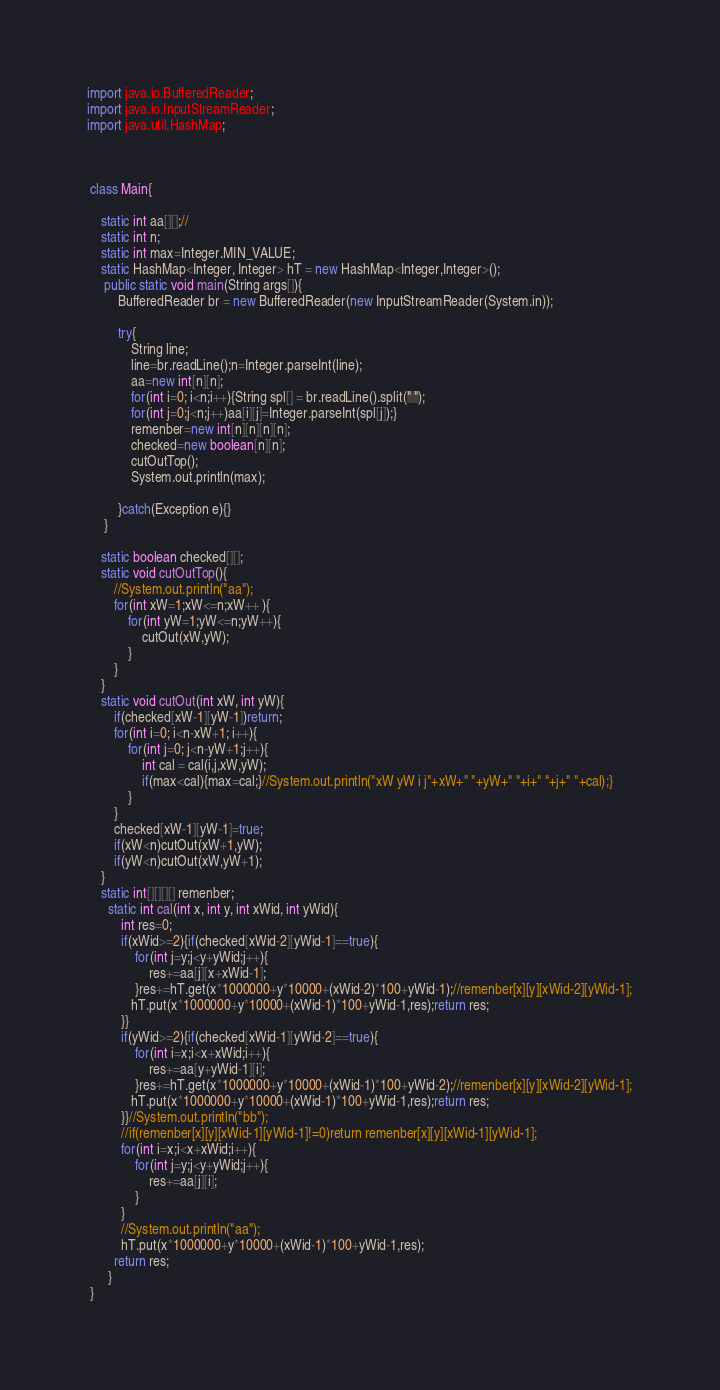Convert code to text. <code><loc_0><loc_0><loc_500><loc_500><_Java_>

import java.io.BufferedReader;
import java.io.InputStreamReader;
import java.util.HashMap;
 
 
 
 class Main{
      
    static int aa[][];//
    static int n;
    static int max=Integer.MIN_VALUE;
    static HashMap<Integer, Integer> hT = new HashMap<Integer,Integer>();
     public static void main(String args[]){
         BufferedReader br = new BufferedReader(new InputStreamReader(System.in));
         
         try{
             String line;
             line=br.readLine();n=Integer.parseInt(line);
             aa=new int[n][n];
             for(int i=0; i<n;i++){String spl[] = br.readLine().split(" ");
             for(int j=0;j<n;j++)aa[i][j]=Integer.parseInt(spl[j]);}
             remenber=new int[n][n][n][n];
             checked=new boolean[n][n];
             cutOutTop();
             System.out.println(max);
             
         }catch(Exception e){}         
     }
      
    static boolean checked[][];
    static void cutOutTop(){
        //System.out.println("aa");
        for(int xW=1;xW<=n;xW++ ){
            for(int yW=1;yW<=n;yW++){
                cutOut(xW,yW);
            }
        }
    }
    static void cutOut(int xW, int yW){
        if(checked[xW-1][yW-1])return;
        for(int i=0; i<n-xW+1; i++){
            for(int j=0; j<n-yW+1;j++){
                int cal = cal(i,j,xW,yW);
                if(max<cal){max=cal;}//System.out.println("xW yW i j"+xW+" "+yW+" "+i+" "+j+" "+cal);}
            }
        }
        checked[xW-1][yW-1]=true;
        if(xW<n)cutOut(xW+1,yW);
        if(yW<n)cutOut(xW,yW+1);
    }
    static int[][][][] remenber;
      static int cal(int x, int y, int xWid, int yWid){
          int res=0;
          if(xWid>=2){if(checked[xWid-2][yWid-1]==true){
              for(int j=y;j<y+yWid;j++){
                  res+=aa[j][x+xWid-1];
              }res+=hT.get(x*1000000+y*10000+(xWid-2)*100+yWid-1);//remenber[x][y][xWid-2][yWid-1];
             hT.put(x*1000000+y*10000+(xWid-1)*100+yWid-1,res);return res;
          }}
          if(yWid>=2){if(checked[xWid-1][yWid-2]==true){
              for(int i=x;i<x+xWid;i++){
                  res+=aa[y+yWid-1][i];
              }res+=hT.get(x*1000000+y*10000+(xWid-1)*100+yWid-2);//remenber[x][y][xWid-2][yWid-1];
             hT.put(x*1000000+y*10000+(xWid-1)*100+yWid-1,res);return res;
          }}//System.out.println("bb");
          //if(remenber[x][y][xWid-1][yWid-1]!=0)return remenber[x][y][xWid-1][yWid-1];
          for(int i=x;i<x+xWid;i++){
              for(int j=y;j<y+yWid;j++){
                  res+=aa[j][i];
              }
          }
          //System.out.println("aa");
          hT.put(x*1000000+y*10000+(xWid-1)*100+yWid-1,res);
        return res;
      }
 }</code> 